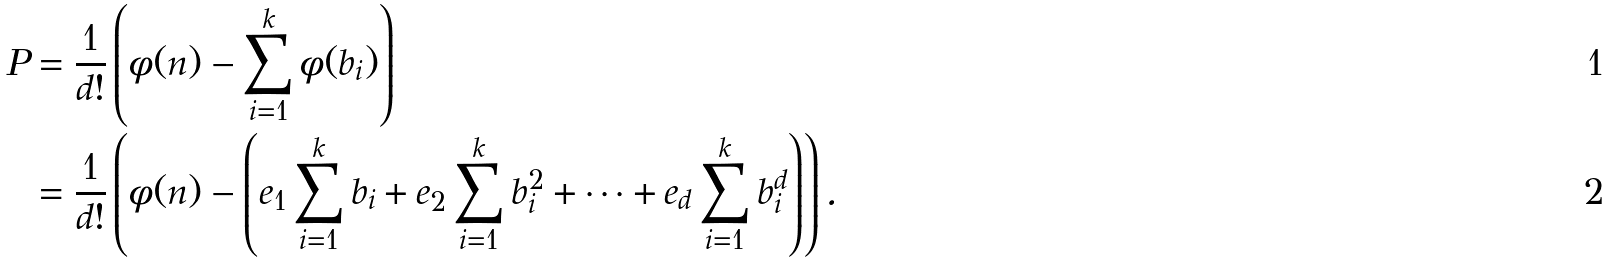Convert formula to latex. <formula><loc_0><loc_0><loc_500><loc_500>P & = \frac { 1 } { d ! } \left ( \phi ( n ) - \sum _ { i = 1 } ^ { k } \phi ( b _ { i } ) \right ) \\ & = \frac { 1 } { d ! } \left ( \phi ( n ) - \left ( e _ { 1 } \sum _ { i = 1 } ^ { k } { b _ { i } } + e _ { 2 } \sum _ { i = 1 } ^ { k } { b _ { i } ^ { 2 } } + \cdots + e _ { d } \sum _ { i = 1 } ^ { k } { b _ { i } ^ { d } } \right ) \right ) .</formula> 